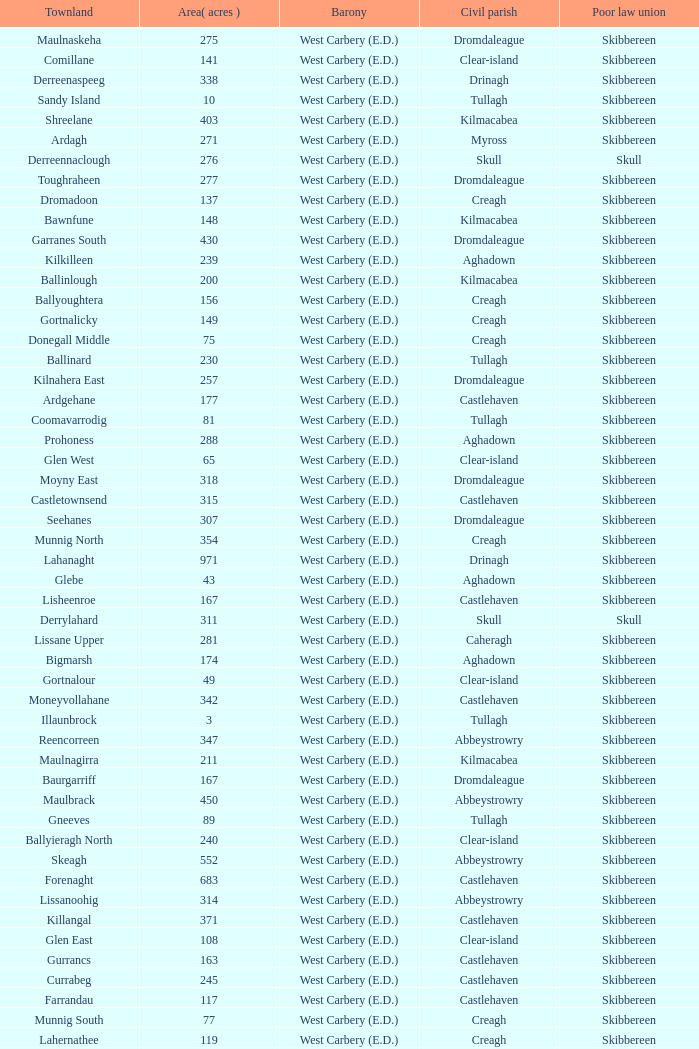What is the greatest area when the Poor Law Union is Skibbereen and the Civil Parish is Tullagh? 796.0. 